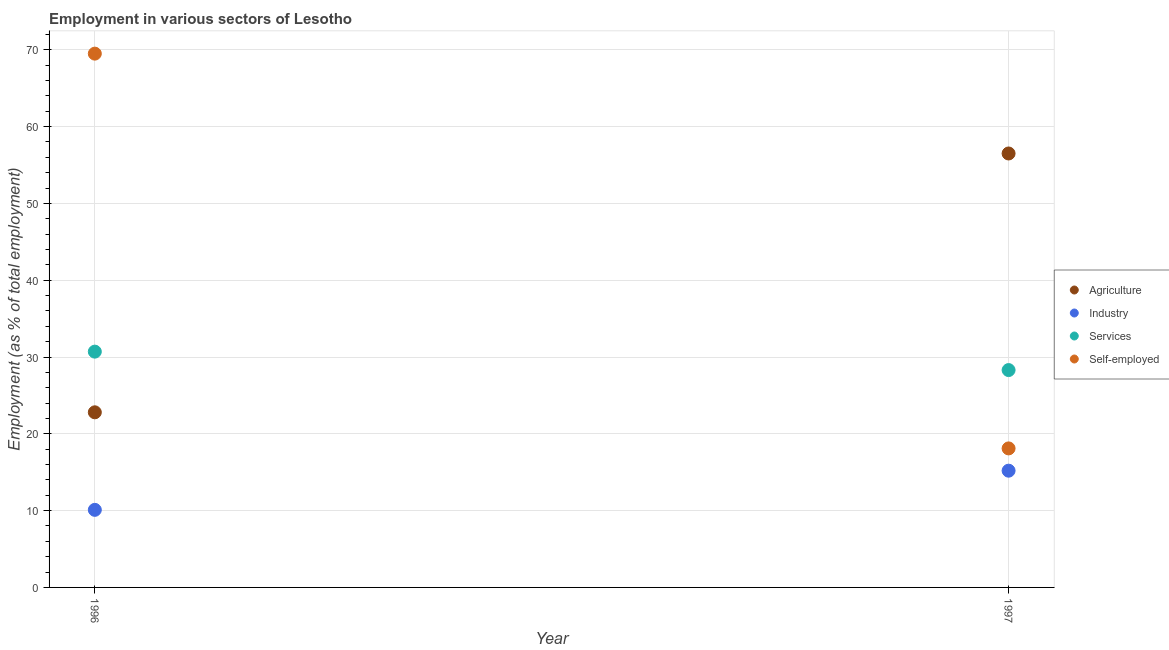What is the percentage of self employed workers in 1996?
Provide a short and direct response. 69.5. Across all years, what is the maximum percentage of workers in services?
Provide a succinct answer. 30.7. Across all years, what is the minimum percentage of workers in services?
Your response must be concise. 28.3. In which year was the percentage of workers in agriculture maximum?
Your response must be concise. 1997. What is the total percentage of self employed workers in the graph?
Offer a very short reply. 87.6. What is the difference between the percentage of workers in services in 1996 and that in 1997?
Your answer should be compact. 2.4. What is the difference between the percentage of workers in industry in 1997 and the percentage of workers in agriculture in 1996?
Give a very brief answer. -7.6. What is the average percentage of workers in industry per year?
Provide a short and direct response. 12.65. In the year 1996, what is the difference between the percentage of self employed workers and percentage of workers in industry?
Your answer should be compact. 59.4. What is the ratio of the percentage of workers in industry in 1996 to that in 1997?
Your response must be concise. 0.66. Is the percentage of workers in services in 1996 less than that in 1997?
Your response must be concise. No. Is it the case that in every year, the sum of the percentage of self employed workers and percentage of workers in industry is greater than the sum of percentage of workers in services and percentage of workers in agriculture?
Offer a terse response. No. Does the percentage of workers in services monotonically increase over the years?
Your answer should be compact. No. How many years are there in the graph?
Your answer should be compact. 2. Are the values on the major ticks of Y-axis written in scientific E-notation?
Your answer should be very brief. No. Where does the legend appear in the graph?
Provide a short and direct response. Center right. What is the title of the graph?
Your answer should be compact. Employment in various sectors of Lesotho. Does "Taxes on exports" appear as one of the legend labels in the graph?
Offer a very short reply. No. What is the label or title of the Y-axis?
Keep it short and to the point. Employment (as % of total employment). What is the Employment (as % of total employment) in Agriculture in 1996?
Provide a short and direct response. 22.8. What is the Employment (as % of total employment) in Industry in 1996?
Your response must be concise. 10.1. What is the Employment (as % of total employment) of Services in 1996?
Your answer should be very brief. 30.7. What is the Employment (as % of total employment) of Self-employed in 1996?
Provide a short and direct response. 69.5. What is the Employment (as % of total employment) in Agriculture in 1997?
Provide a short and direct response. 56.5. What is the Employment (as % of total employment) in Industry in 1997?
Your response must be concise. 15.2. What is the Employment (as % of total employment) of Services in 1997?
Provide a succinct answer. 28.3. What is the Employment (as % of total employment) of Self-employed in 1997?
Your response must be concise. 18.1. Across all years, what is the maximum Employment (as % of total employment) in Agriculture?
Your response must be concise. 56.5. Across all years, what is the maximum Employment (as % of total employment) in Industry?
Offer a terse response. 15.2. Across all years, what is the maximum Employment (as % of total employment) in Services?
Your answer should be compact. 30.7. Across all years, what is the maximum Employment (as % of total employment) of Self-employed?
Offer a very short reply. 69.5. Across all years, what is the minimum Employment (as % of total employment) of Agriculture?
Ensure brevity in your answer.  22.8. Across all years, what is the minimum Employment (as % of total employment) in Industry?
Offer a terse response. 10.1. Across all years, what is the minimum Employment (as % of total employment) in Services?
Give a very brief answer. 28.3. Across all years, what is the minimum Employment (as % of total employment) of Self-employed?
Offer a terse response. 18.1. What is the total Employment (as % of total employment) in Agriculture in the graph?
Keep it short and to the point. 79.3. What is the total Employment (as % of total employment) of Industry in the graph?
Give a very brief answer. 25.3. What is the total Employment (as % of total employment) of Self-employed in the graph?
Your response must be concise. 87.6. What is the difference between the Employment (as % of total employment) in Agriculture in 1996 and that in 1997?
Offer a terse response. -33.7. What is the difference between the Employment (as % of total employment) of Services in 1996 and that in 1997?
Your answer should be very brief. 2.4. What is the difference between the Employment (as % of total employment) in Self-employed in 1996 and that in 1997?
Make the answer very short. 51.4. What is the difference between the Employment (as % of total employment) in Agriculture in 1996 and the Employment (as % of total employment) in Industry in 1997?
Keep it short and to the point. 7.6. What is the difference between the Employment (as % of total employment) of Agriculture in 1996 and the Employment (as % of total employment) of Services in 1997?
Provide a succinct answer. -5.5. What is the difference between the Employment (as % of total employment) of Industry in 1996 and the Employment (as % of total employment) of Services in 1997?
Provide a short and direct response. -18.2. What is the difference between the Employment (as % of total employment) in Industry in 1996 and the Employment (as % of total employment) in Self-employed in 1997?
Give a very brief answer. -8. What is the average Employment (as % of total employment) of Agriculture per year?
Ensure brevity in your answer.  39.65. What is the average Employment (as % of total employment) in Industry per year?
Keep it short and to the point. 12.65. What is the average Employment (as % of total employment) of Services per year?
Give a very brief answer. 29.5. What is the average Employment (as % of total employment) of Self-employed per year?
Make the answer very short. 43.8. In the year 1996, what is the difference between the Employment (as % of total employment) in Agriculture and Employment (as % of total employment) in Industry?
Offer a terse response. 12.7. In the year 1996, what is the difference between the Employment (as % of total employment) of Agriculture and Employment (as % of total employment) of Services?
Ensure brevity in your answer.  -7.9. In the year 1996, what is the difference between the Employment (as % of total employment) in Agriculture and Employment (as % of total employment) in Self-employed?
Your response must be concise. -46.7. In the year 1996, what is the difference between the Employment (as % of total employment) of Industry and Employment (as % of total employment) of Services?
Give a very brief answer. -20.6. In the year 1996, what is the difference between the Employment (as % of total employment) of Industry and Employment (as % of total employment) of Self-employed?
Your answer should be very brief. -59.4. In the year 1996, what is the difference between the Employment (as % of total employment) in Services and Employment (as % of total employment) in Self-employed?
Your response must be concise. -38.8. In the year 1997, what is the difference between the Employment (as % of total employment) of Agriculture and Employment (as % of total employment) of Industry?
Keep it short and to the point. 41.3. In the year 1997, what is the difference between the Employment (as % of total employment) in Agriculture and Employment (as % of total employment) in Services?
Provide a succinct answer. 28.2. In the year 1997, what is the difference between the Employment (as % of total employment) of Agriculture and Employment (as % of total employment) of Self-employed?
Ensure brevity in your answer.  38.4. In the year 1997, what is the difference between the Employment (as % of total employment) of Industry and Employment (as % of total employment) of Services?
Make the answer very short. -13.1. What is the ratio of the Employment (as % of total employment) of Agriculture in 1996 to that in 1997?
Your response must be concise. 0.4. What is the ratio of the Employment (as % of total employment) of Industry in 1996 to that in 1997?
Ensure brevity in your answer.  0.66. What is the ratio of the Employment (as % of total employment) in Services in 1996 to that in 1997?
Give a very brief answer. 1.08. What is the ratio of the Employment (as % of total employment) in Self-employed in 1996 to that in 1997?
Give a very brief answer. 3.84. What is the difference between the highest and the second highest Employment (as % of total employment) in Agriculture?
Your answer should be very brief. 33.7. What is the difference between the highest and the second highest Employment (as % of total employment) of Industry?
Your response must be concise. 5.1. What is the difference between the highest and the second highest Employment (as % of total employment) of Self-employed?
Provide a succinct answer. 51.4. What is the difference between the highest and the lowest Employment (as % of total employment) in Agriculture?
Provide a short and direct response. 33.7. What is the difference between the highest and the lowest Employment (as % of total employment) in Services?
Your answer should be very brief. 2.4. What is the difference between the highest and the lowest Employment (as % of total employment) in Self-employed?
Give a very brief answer. 51.4. 